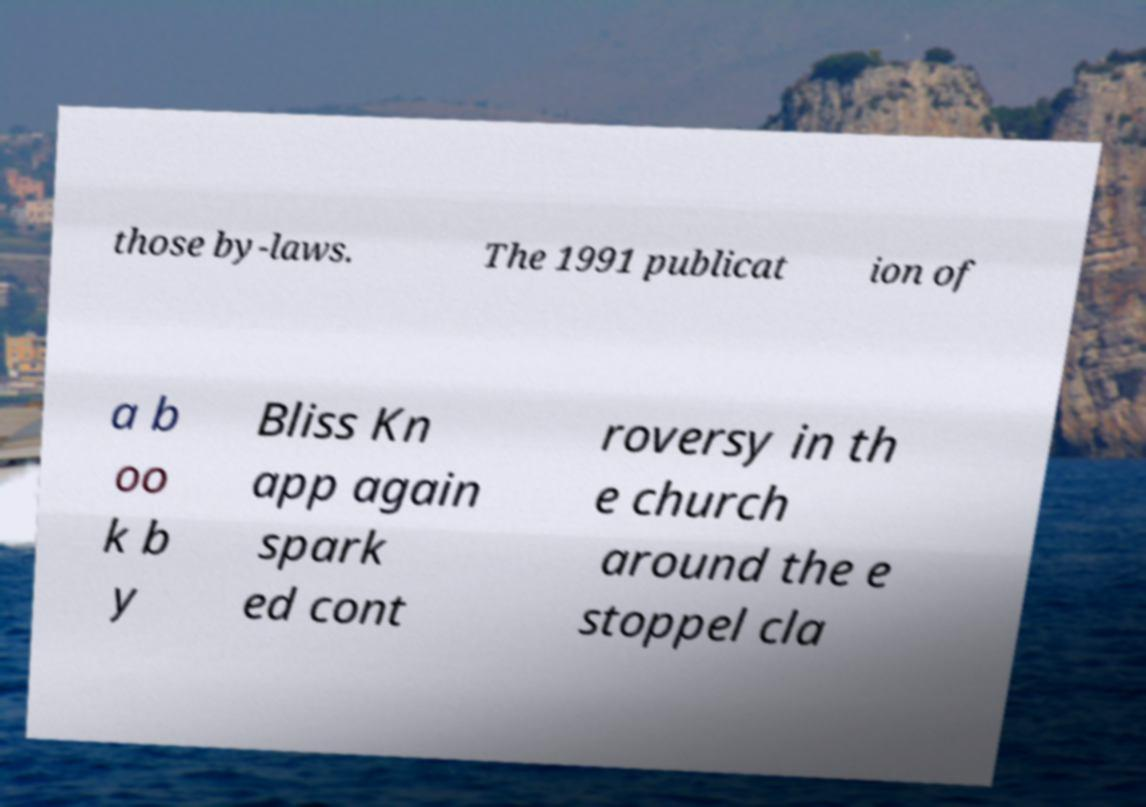For documentation purposes, I need the text within this image transcribed. Could you provide that? those by-laws. The 1991 publicat ion of a b oo k b y Bliss Kn app again spark ed cont roversy in th e church around the e stoppel cla 